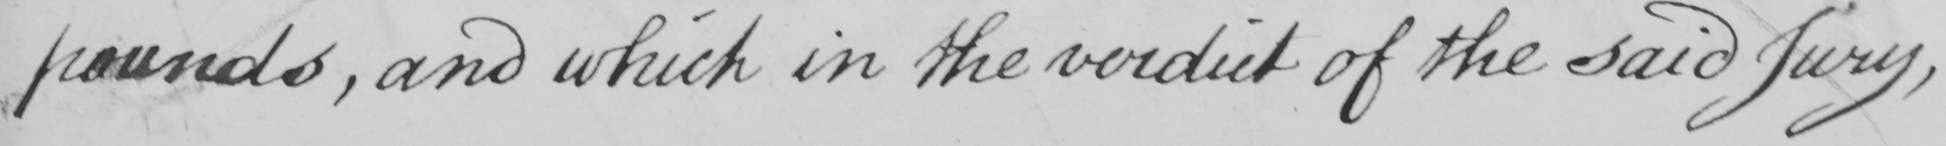What does this handwritten line say? pounds , and which in the verdict of the said jury , 